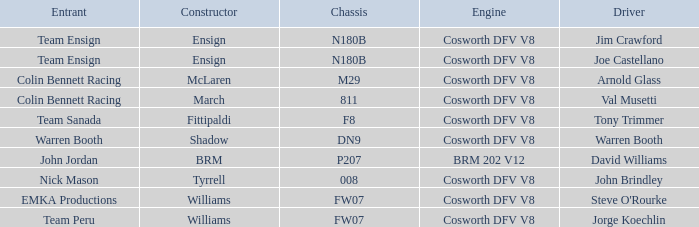What team used the BRM built car? John Jordan. 